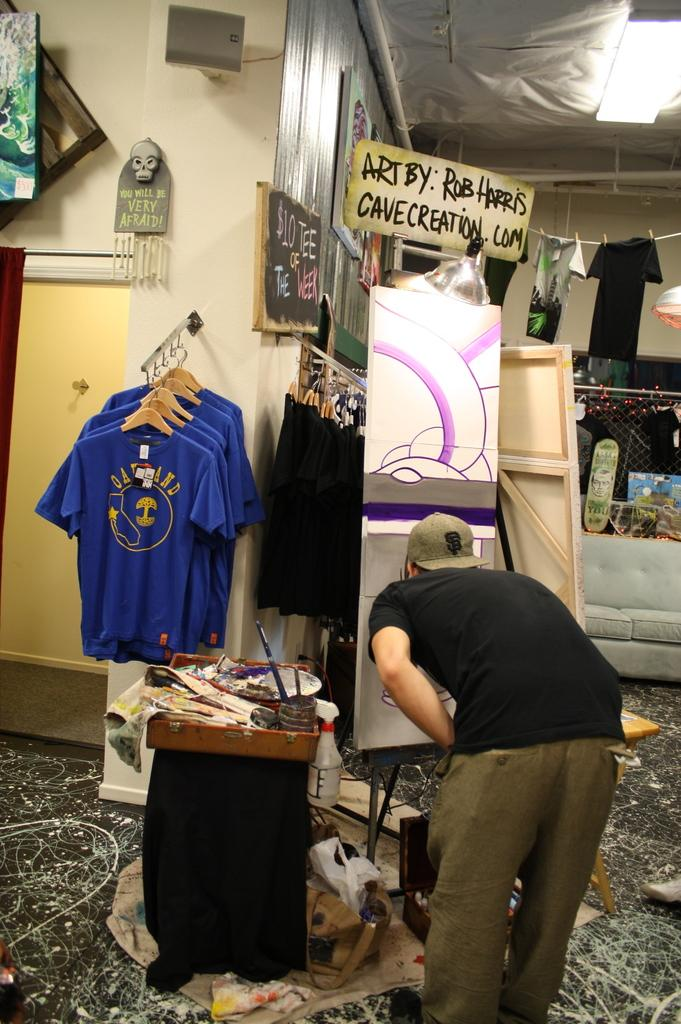<image>
Present a compact description of the photo's key features. A man is sketching on an easel in a store under a sign that says "Art By: Rob Harris Cavecreation.com. 